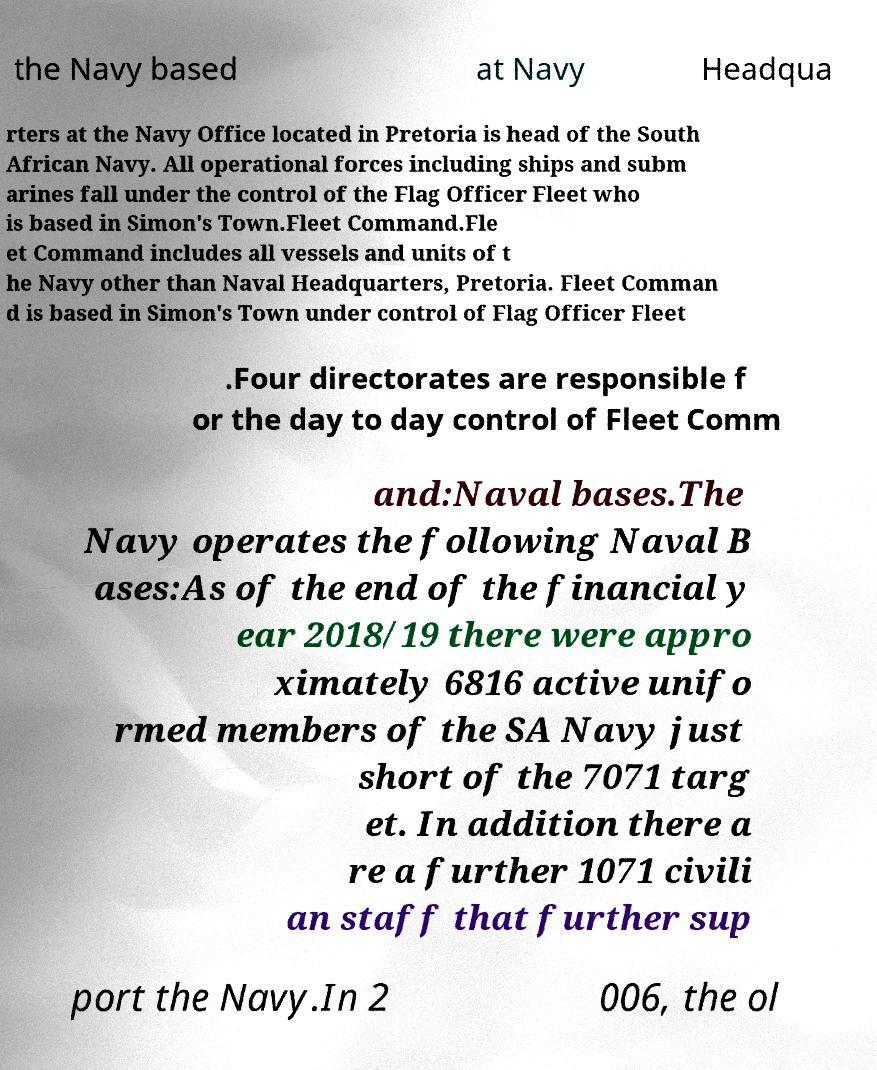Could you assist in decoding the text presented in this image and type it out clearly? the Navy based at Navy Headqua rters at the Navy Office located in Pretoria is head of the South African Navy. All operational forces including ships and subm arines fall under the control of the Flag Officer Fleet who is based in Simon's Town.Fleet Command.Fle et Command includes all vessels and units of t he Navy other than Naval Headquarters, Pretoria. Fleet Comman d is based in Simon's Town under control of Flag Officer Fleet .Four directorates are responsible f or the day to day control of Fleet Comm and:Naval bases.The Navy operates the following Naval B ases:As of the end of the financial y ear 2018/19 there were appro ximately 6816 active unifo rmed members of the SA Navy just short of the 7071 targ et. In addition there a re a further 1071 civili an staff that further sup port the Navy.In 2 006, the ol 